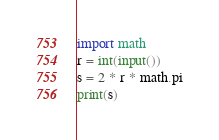<code> <loc_0><loc_0><loc_500><loc_500><_Python_>import math
r = int(input())
s = 2 * r * math.pi
print(s)</code> 